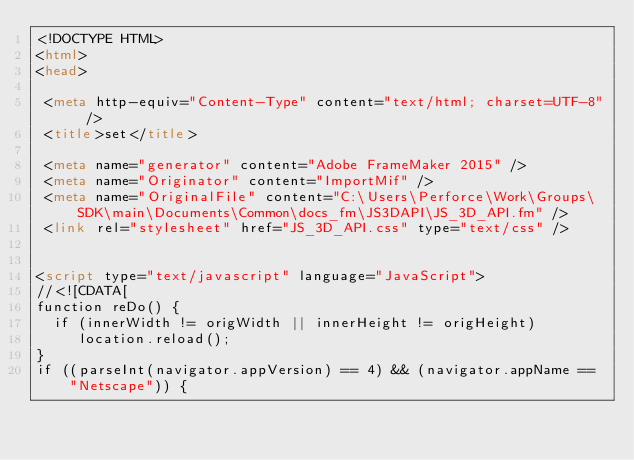Convert code to text. <code><loc_0><loc_0><loc_500><loc_500><_HTML_><!DOCTYPE HTML>
<html>
<head>

 <meta http-equiv="Content-Type" content="text/html; charset=UTF-8" />
 <title>set</title>

 <meta name="generator" content="Adobe FrameMaker 2015" />
 <meta name="Originator" content="ImportMif" />
 <meta name="OriginalFile" content="C:\Users\Perforce\Work\Groups\SDK\main\Documents\Common\docs_fm\JS3DAPI\JS_3D_API.fm" />
 <link rel="stylesheet" href="JS_3D_API.css" type="text/css" />


<script type="text/javascript" language="JavaScript">
//<![CDATA[
function reDo() {
  if (innerWidth != origWidth || innerHeight != origHeight)
     location.reload();
}
if ((parseInt(navigator.appVersion) == 4) && (navigator.appName == "Netscape")) {</code> 